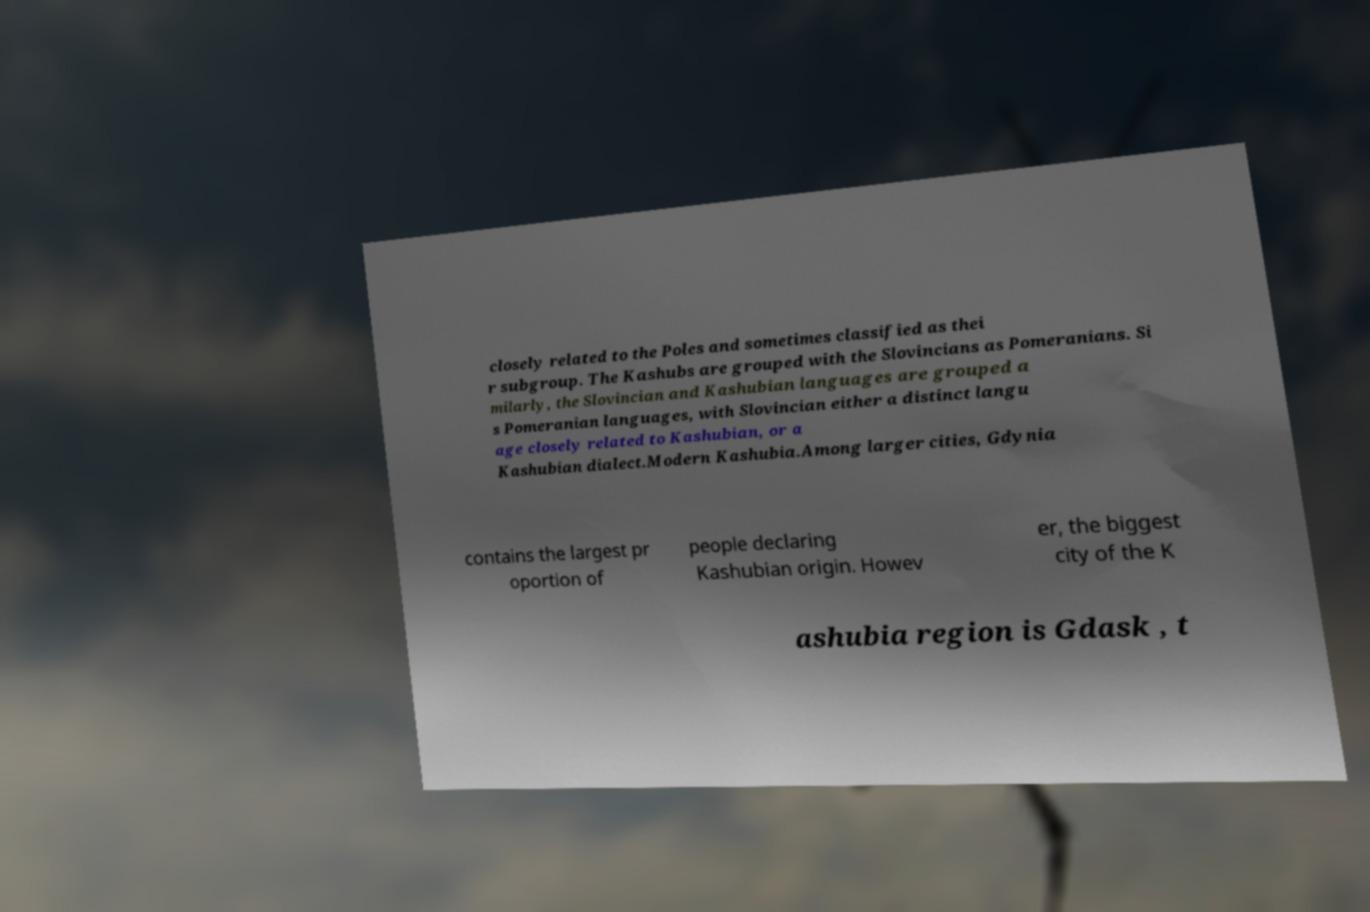Could you extract and type out the text from this image? closely related to the Poles and sometimes classified as thei r subgroup. The Kashubs are grouped with the Slovincians as Pomeranians. Si milarly, the Slovincian and Kashubian languages are grouped a s Pomeranian languages, with Slovincian either a distinct langu age closely related to Kashubian, or a Kashubian dialect.Modern Kashubia.Among larger cities, Gdynia contains the largest pr oportion of people declaring Kashubian origin. Howev er, the biggest city of the K ashubia region is Gdask , t 